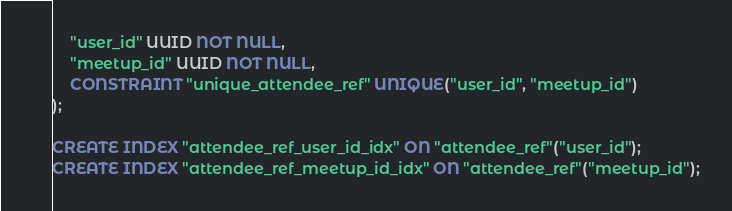<code> <loc_0><loc_0><loc_500><loc_500><_SQL_>    "user_id" UUID NOT NULL,
    "meetup_id" UUID NOT NULL,
    CONSTRAINT "unique_attendee_ref" UNIQUE("user_id", "meetup_id")
);

CREATE INDEX "attendee_ref_user_id_idx" ON "attendee_ref"("user_id");
CREATE INDEX "attendee_ref_meetup_id_idx" ON "attendee_ref"("meetup_id");
</code> 